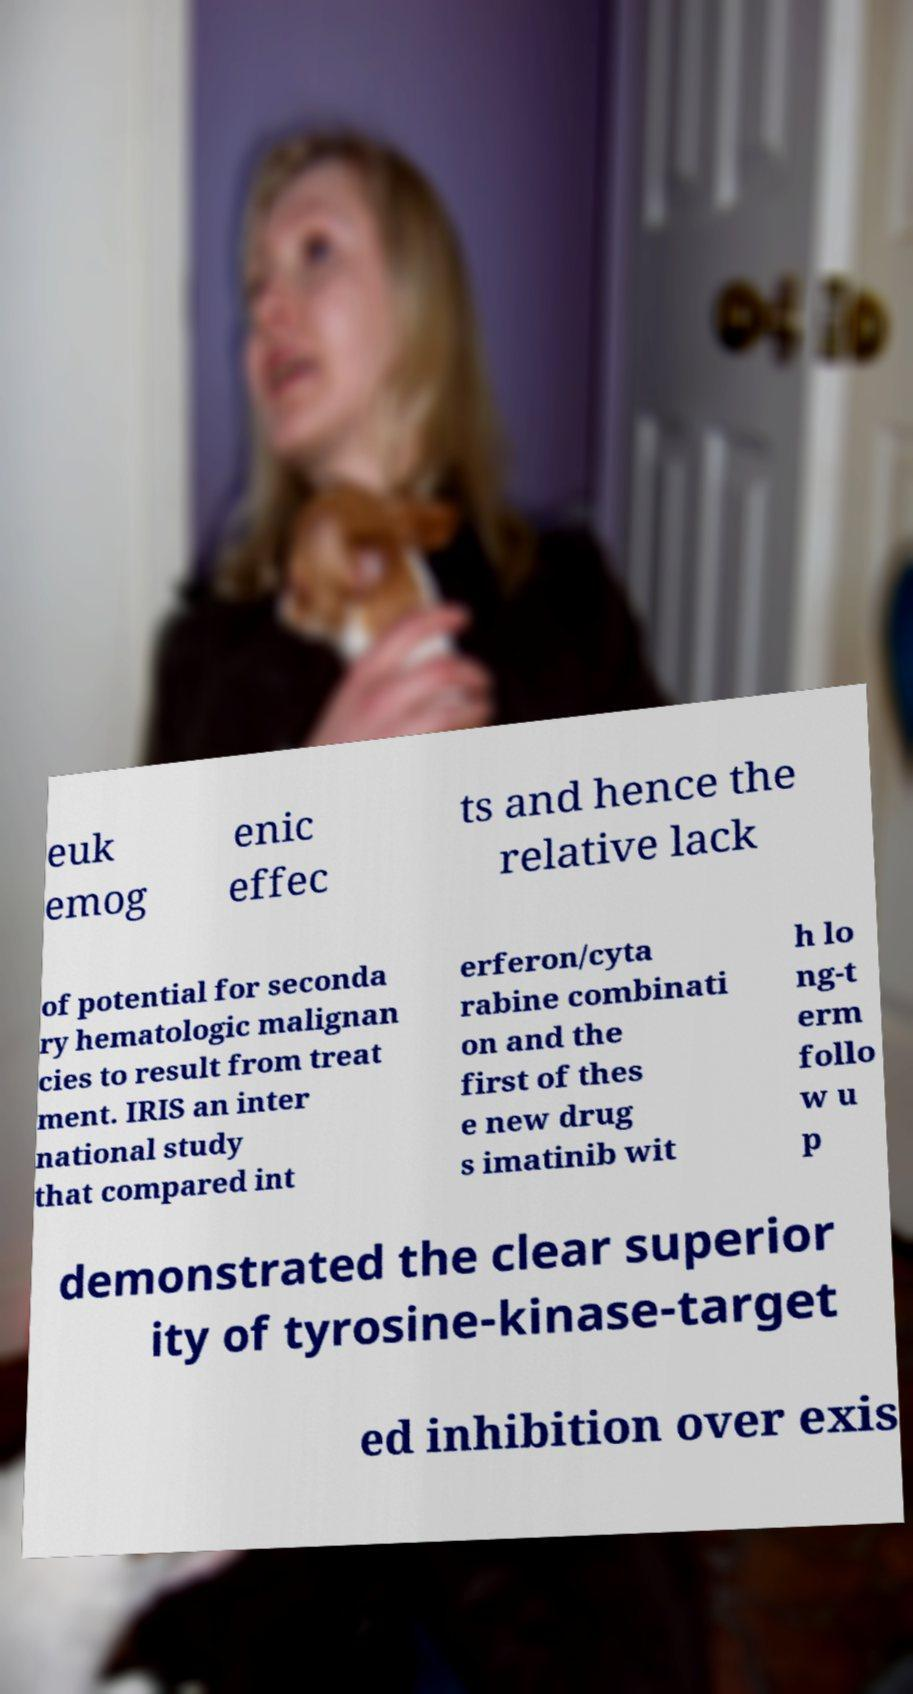Could you extract and type out the text from this image? euk emog enic effec ts and hence the relative lack of potential for seconda ry hematologic malignan cies to result from treat ment. IRIS an inter national study that compared int erferon/cyta rabine combinati on and the first of thes e new drug s imatinib wit h lo ng-t erm follo w u p demonstrated the clear superior ity of tyrosine-kinase-target ed inhibition over exis 